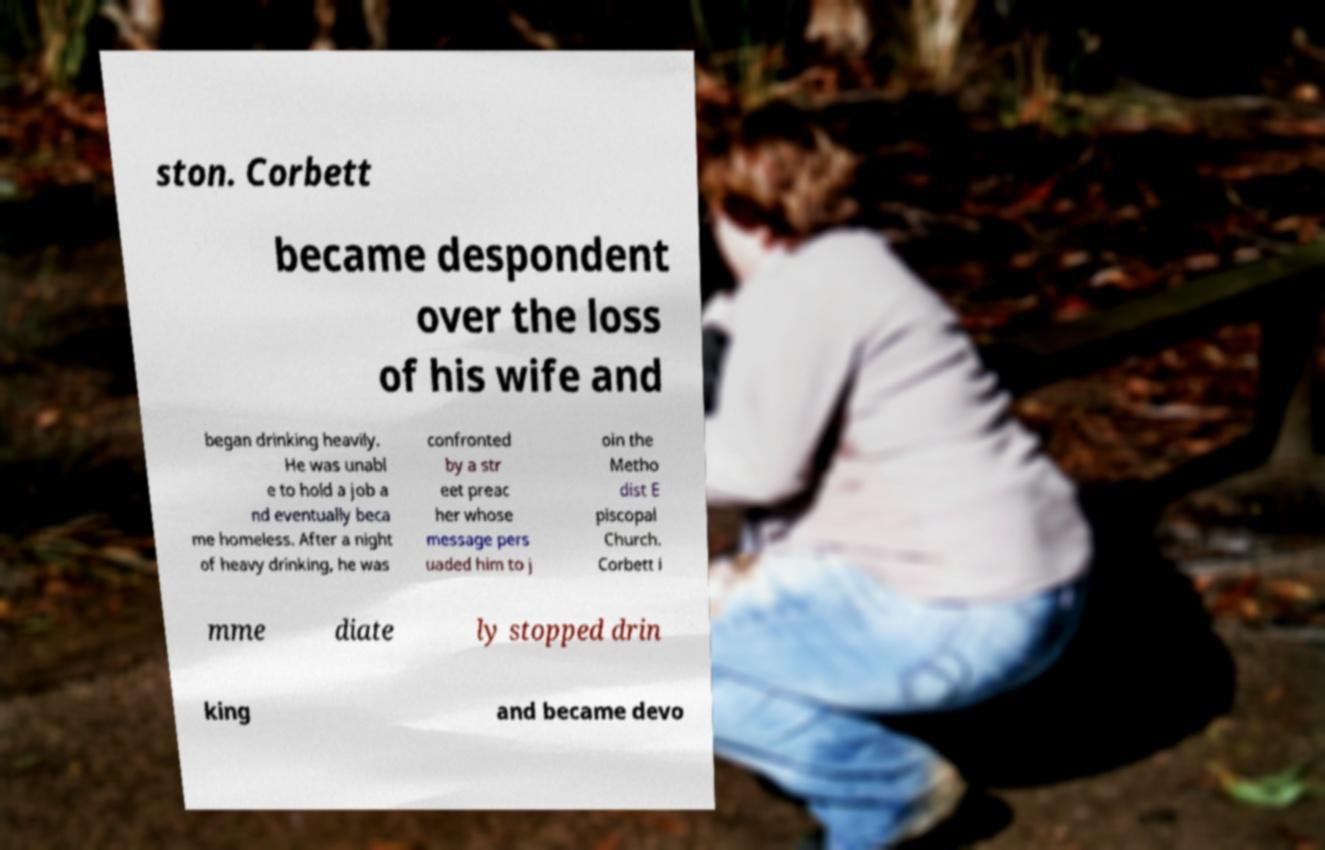Can you accurately transcribe the text from the provided image for me? ston. Corbett became despondent over the loss of his wife and began drinking heavily. He was unabl e to hold a job a nd eventually beca me homeless. After a night of heavy drinking, he was confronted by a str eet preac her whose message pers uaded him to j oin the Metho dist E piscopal Church. Corbett i mme diate ly stopped drin king and became devo 